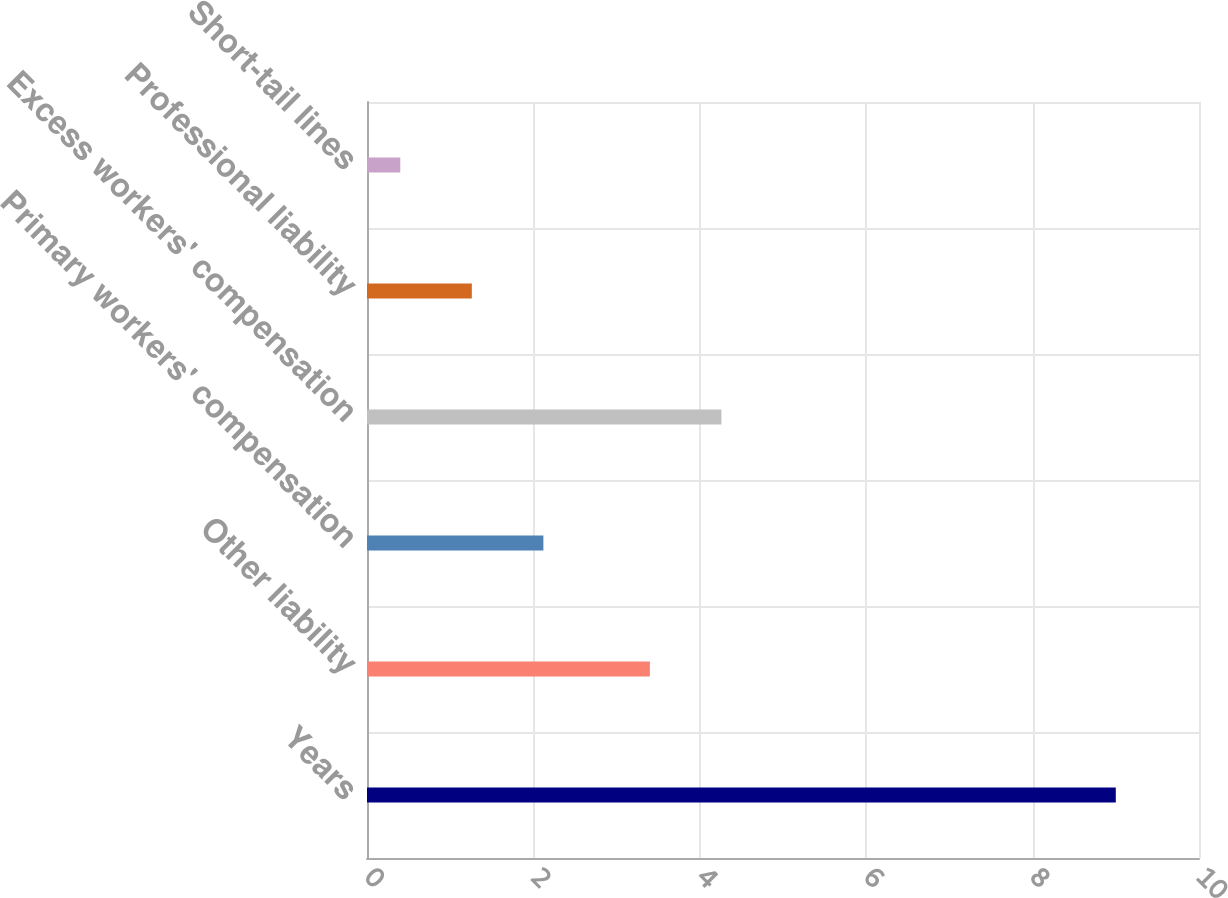<chart> <loc_0><loc_0><loc_500><loc_500><bar_chart><fcel>Years<fcel>Other liability<fcel>Primary workers' compensation<fcel>Excess workers' compensation<fcel>Professional liability<fcel>Short-tail lines<nl><fcel>9<fcel>3.4<fcel>2.12<fcel>4.26<fcel>1.26<fcel>0.4<nl></chart> 